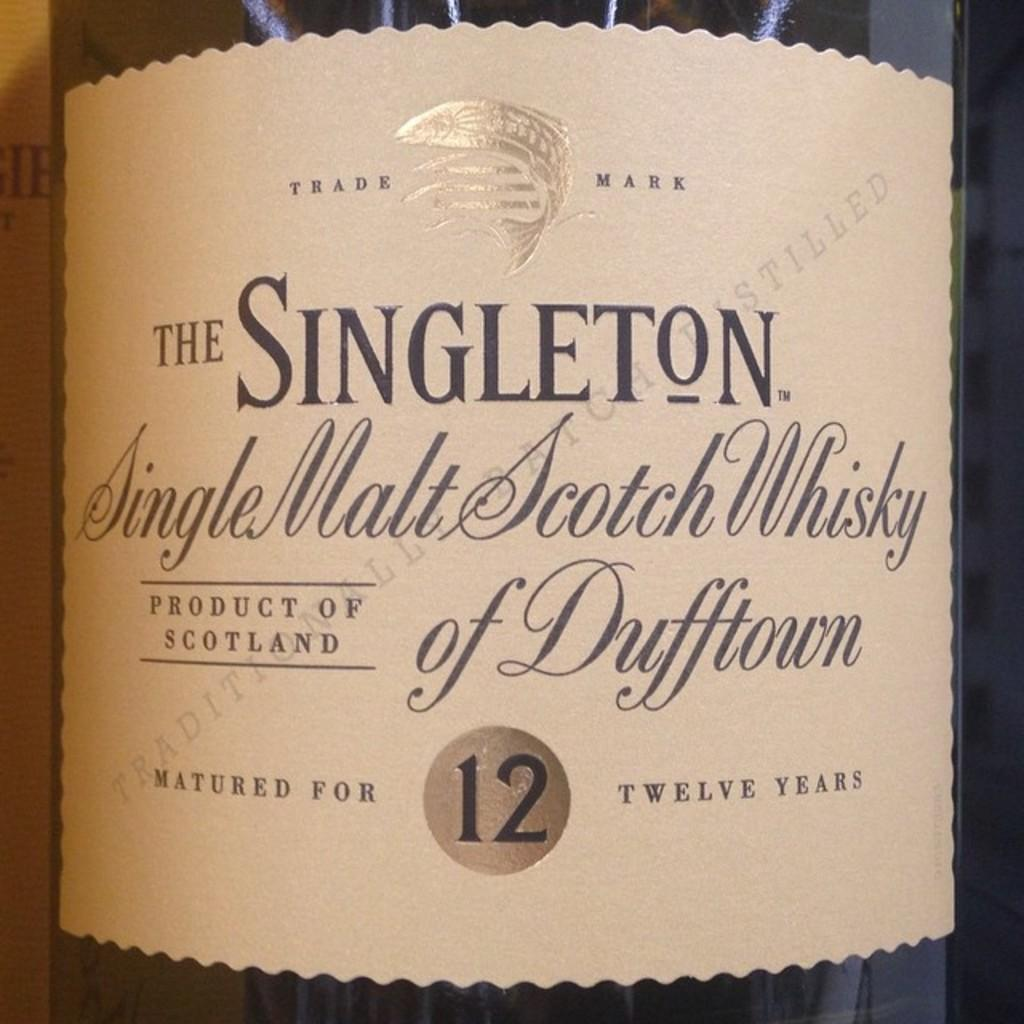Provide a one-sentence caption for the provided image. A bottle of Singleton Single Malt Scotch Whisky. 